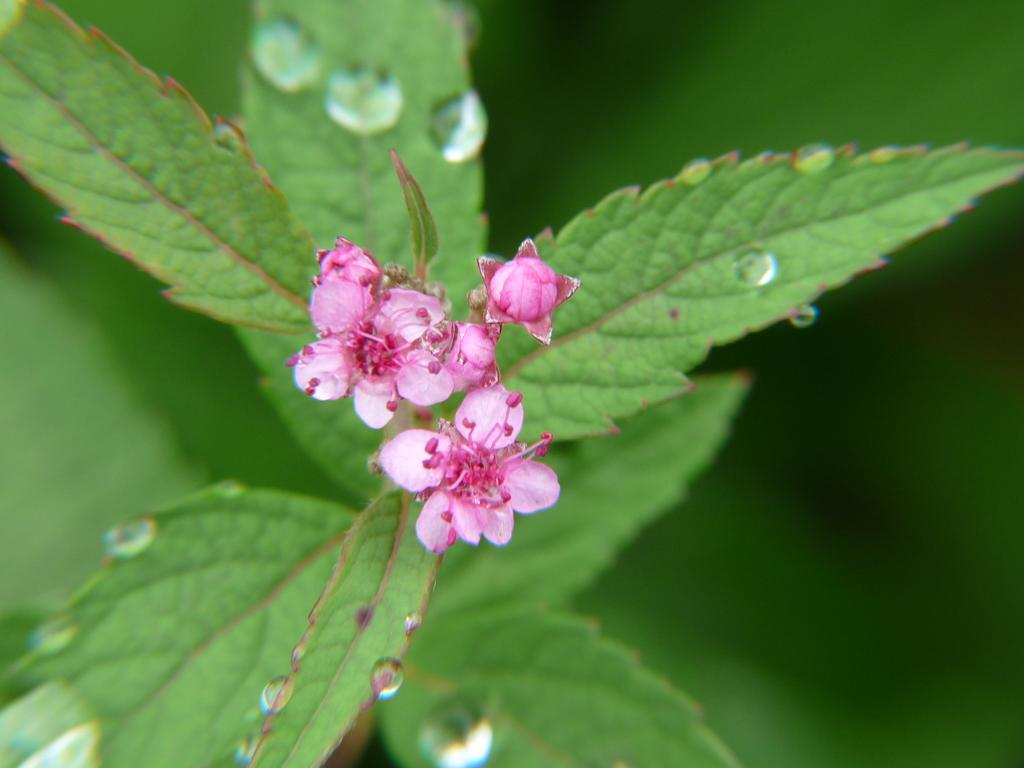What color are the flowers on the plant in the image? The flowers on the plant are pink in color. What other part of the plant can be seen in the image? There are green color leaves on the plant. What is present on the leaves of the plant? There are water droplets on the leaves. How would you describe the background of the image? The background of the image is blurred. What type of payment is being made for the plant in the image? There is no indication of any payment being made in the image; it simply shows a plant with flowers and leaves. 